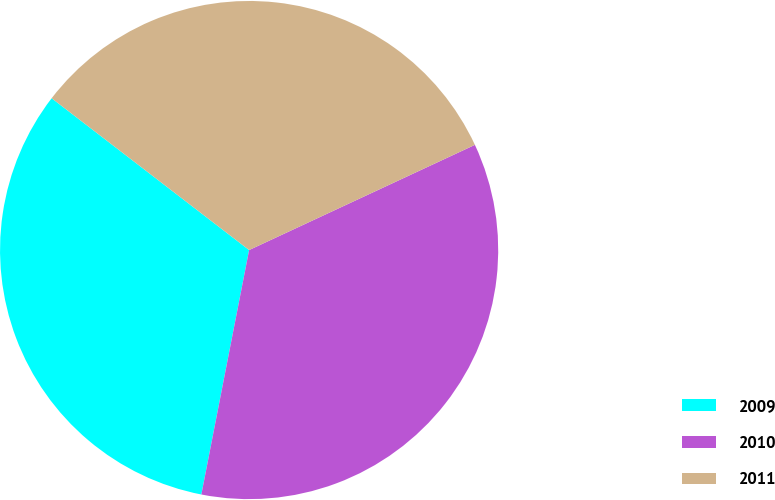Convert chart. <chart><loc_0><loc_0><loc_500><loc_500><pie_chart><fcel>2009<fcel>2010<fcel>2011<nl><fcel>32.36%<fcel>35.01%<fcel>32.63%<nl></chart> 